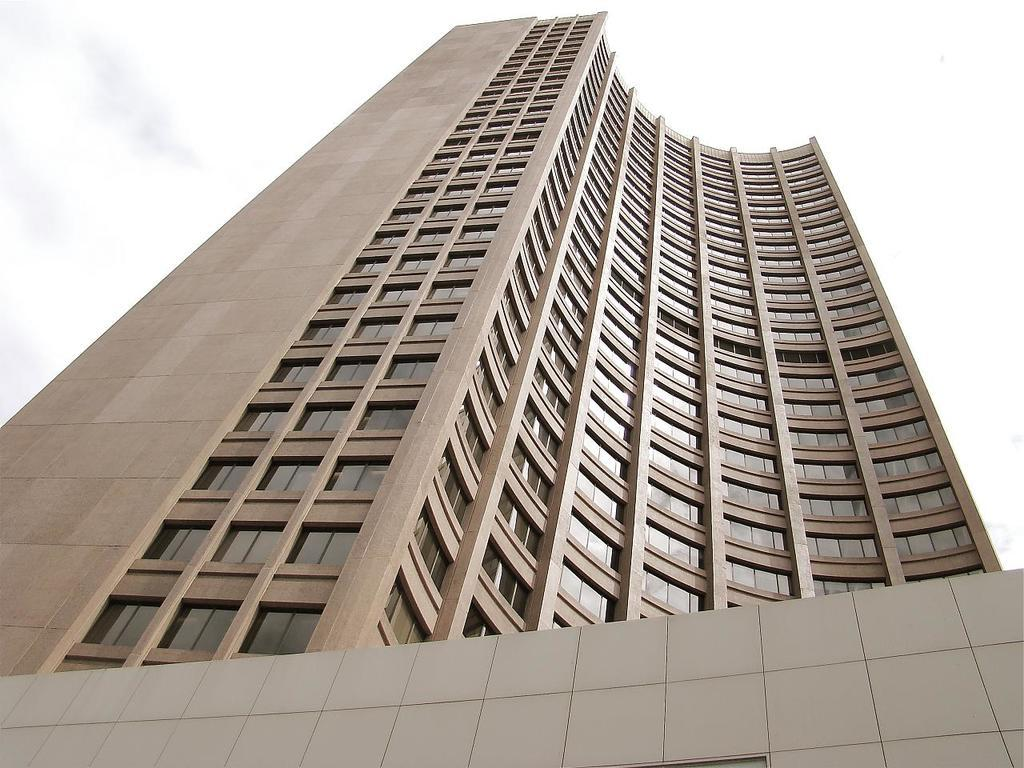What is the main structure in the image? There is a building in the image. What color is the building? The building is brown in color. What can be seen in the background of the image? There is a sky visible in the background of the image. What is the condition of the sky in the image? There are clouds in the sky. Can you tell me how many people are involved in the argument in the image? There is no argument present in the image; it features a brown building with a sky and clouds in the background. What type of curve can be seen on the building in the image? There is no curve visible on the building in the image; it is a simple, brown structure. 